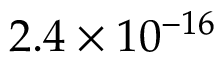Convert formula to latex. <formula><loc_0><loc_0><loc_500><loc_500>2 . 4 \times 1 0 ^ { - 1 6 }</formula> 